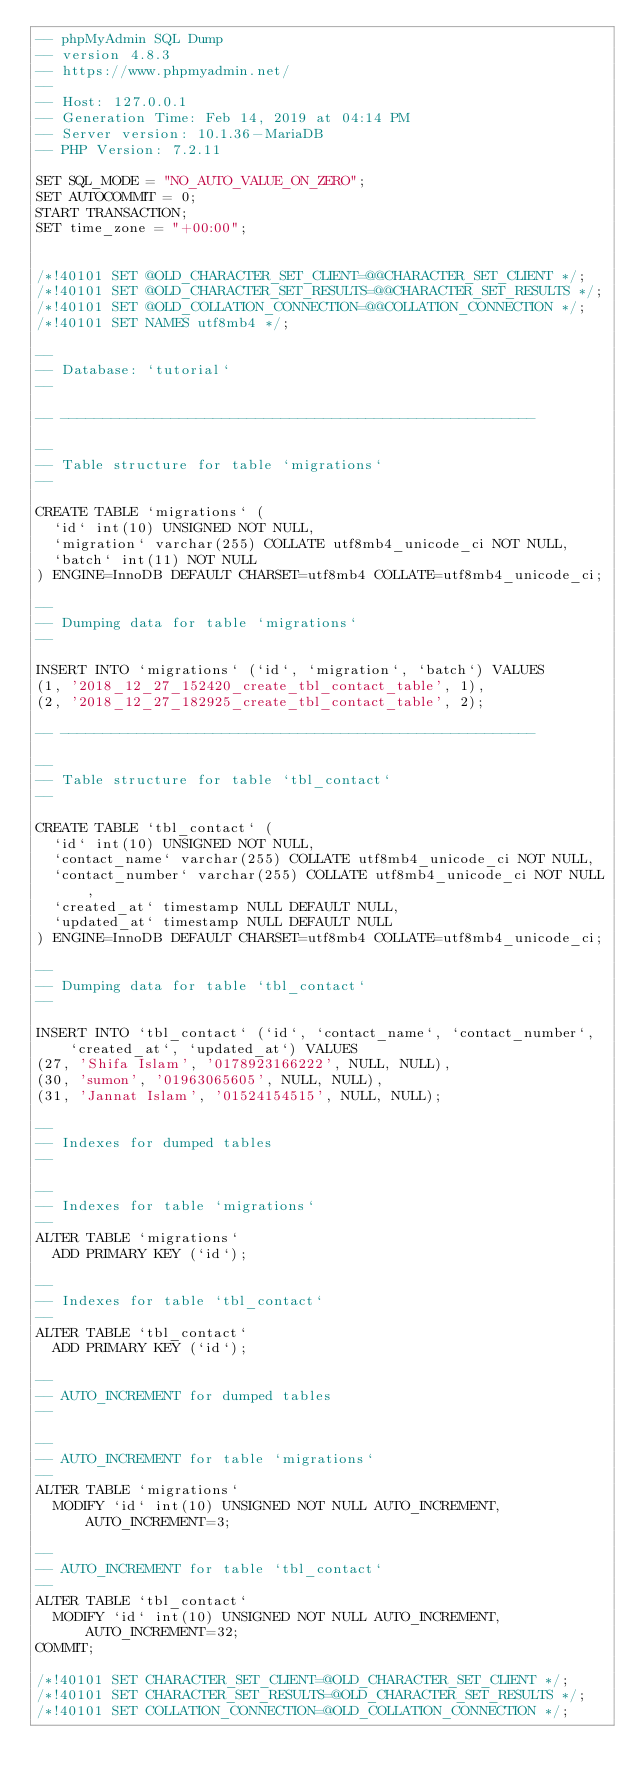<code> <loc_0><loc_0><loc_500><loc_500><_SQL_>-- phpMyAdmin SQL Dump
-- version 4.8.3
-- https://www.phpmyadmin.net/
--
-- Host: 127.0.0.1
-- Generation Time: Feb 14, 2019 at 04:14 PM
-- Server version: 10.1.36-MariaDB
-- PHP Version: 7.2.11

SET SQL_MODE = "NO_AUTO_VALUE_ON_ZERO";
SET AUTOCOMMIT = 0;
START TRANSACTION;
SET time_zone = "+00:00";


/*!40101 SET @OLD_CHARACTER_SET_CLIENT=@@CHARACTER_SET_CLIENT */;
/*!40101 SET @OLD_CHARACTER_SET_RESULTS=@@CHARACTER_SET_RESULTS */;
/*!40101 SET @OLD_COLLATION_CONNECTION=@@COLLATION_CONNECTION */;
/*!40101 SET NAMES utf8mb4 */;

--
-- Database: `tutorial`
--

-- --------------------------------------------------------

--
-- Table structure for table `migrations`
--

CREATE TABLE `migrations` (
  `id` int(10) UNSIGNED NOT NULL,
  `migration` varchar(255) COLLATE utf8mb4_unicode_ci NOT NULL,
  `batch` int(11) NOT NULL
) ENGINE=InnoDB DEFAULT CHARSET=utf8mb4 COLLATE=utf8mb4_unicode_ci;

--
-- Dumping data for table `migrations`
--

INSERT INTO `migrations` (`id`, `migration`, `batch`) VALUES
(1, '2018_12_27_152420_create_tbl_contact_table', 1),
(2, '2018_12_27_182925_create_tbl_contact_table', 2);

-- --------------------------------------------------------

--
-- Table structure for table `tbl_contact`
--

CREATE TABLE `tbl_contact` (
  `id` int(10) UNSIGNED NOT NULL,
  `contact_name` varchar(255) COLLATE utf8mb4_unicode_ci NOT NULL,
  `contact_number` varchar(255) COLLATE utf8mb4_unicode_ci NOT NULL,
  `created_at` timestamp NULL DEFAULT NULL,
  `updated_at` timestamp NULL DEFAULT NULL
) ENGINE=InnoDB DEFAULT CHARSET=utf8mb4 COLLATE=utf8mb4_unicode_ci;

--
-- Dumping data for table `tbl_contact`
--

INSERT INTO `tbl_contact` (`id`, `contact_name`, `contact_number`, `created_at`, `updated_at`) VALUES
(27, 'Shifa Islam', '0178923166222', NULL, NULL),
(30, 'sumon', '01963065605', NULL, NULL),
(31, 'Jannat Islam', '01524154515', NULL, NULL);

--
-- Indexes for dumped tables
--

--
-- Indexes for table `migrations`
--
ALTER TABLE `migrations`
  ADD PRIMARY KEY (`id`);

--
-- Indexes for table `tbl_contact`
--
ALTER TABLE `tbl_contact`
  ADD PRIMARY KEY (`id`);

--
-- AUTO_INCREMENT for dumped tables
--

--
-- AUTO_INCREMENT for table `migrations`
--
ALTER TABLE `migrations`
  MODIFY `id` int(10) UNSIGNED NOT NULL AUTO_INCREMENT, AUTO_INCREMENT=3;

--
-- AUTO_INCREMENT for table `tbl_contact`
--
ALTER TABLE `tbl_contact`
  MODIFY `id` int(10) UNSIGNED NOT NULL AUTO_INCREMENT, AUTO_INCREMENT=32;
COMMIT;

/*!40101 SET CHARACTER_SET_CLIENT=@OLD_CHARACTER_SET_CLIENT */;
/*!40101 SET CHARACTER_SET_RESULTS=@OLD_CHARACTER_SET_RESULTS */;
/*!40101 SET COLLATION_CONNECTION=@OLD_COLLATION_CONNECTION */;
</code> 